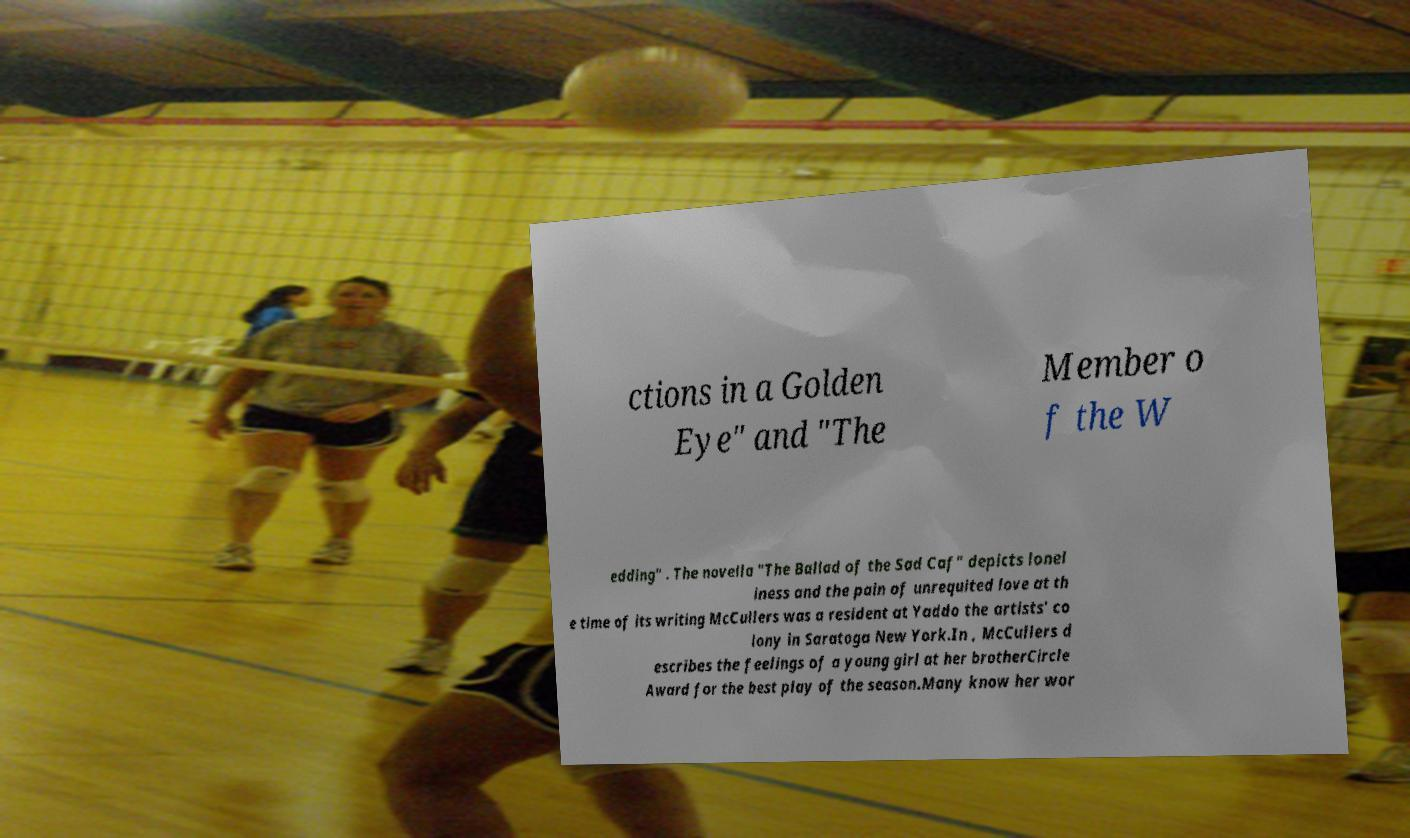Please read and relay the text visible in this image. What does it say? ctions in a Golden Eye" and "The Member o f the W edding" . The novella "The Ballad of the Sad Caf" depicts lonel iness and the pain of unrequited love at th e time of its writing McCullers was a resident at Yaddo the artists' co lony in Saratoga New York.In , McCullers d escribes the feelings of a young girl at her brotherCircle Award for the best play of the season.Many know her wor 